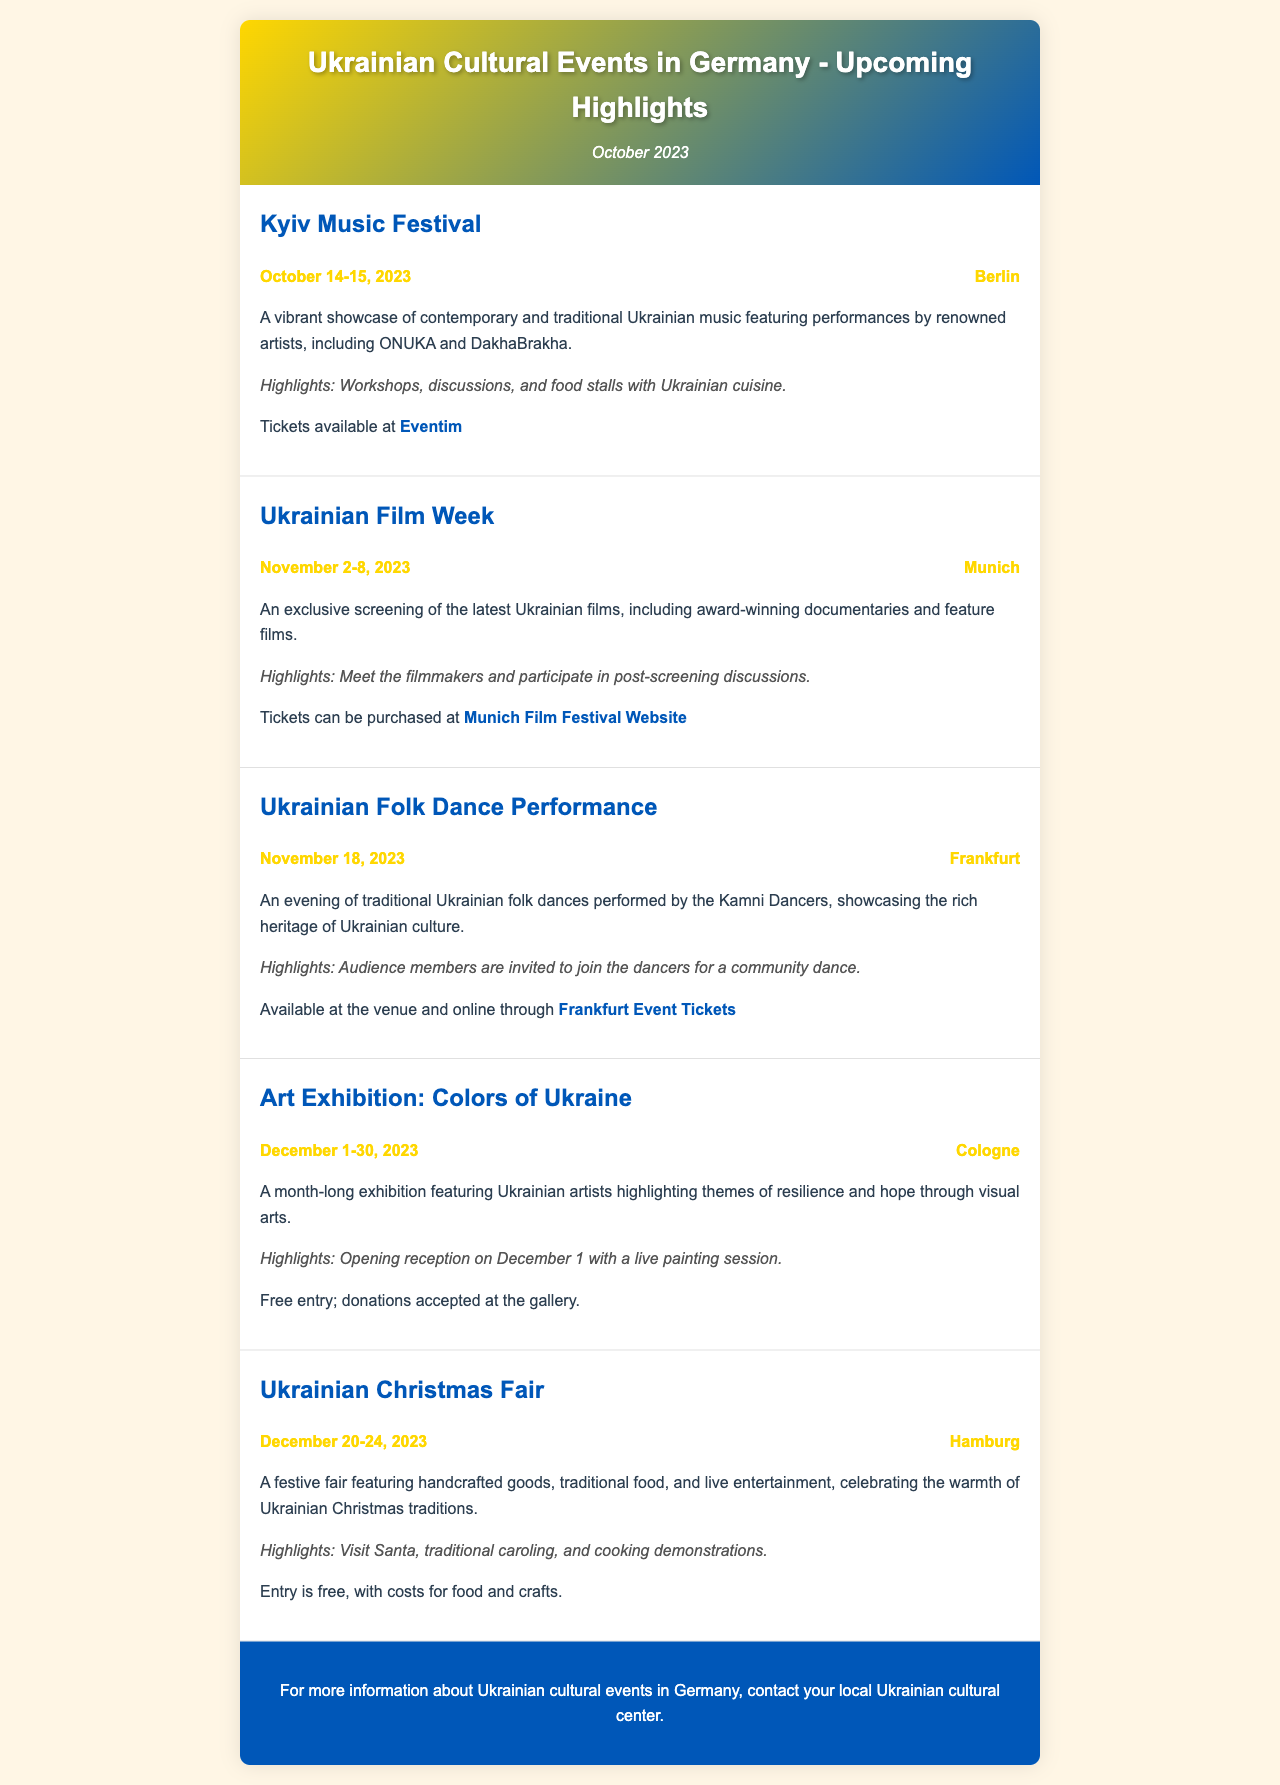What is the name of the festival in Berlin? The document lists the "Kyiv Music Festival" as the festival taking place in Berlin.
Answer: Kyiv Music Festival When is the Ukrainian Film Week scheduled? The document indicates that the Ukrainian Film Week is scheduled for November 2-8, 2023.
Answer: November 2-8, 2023 What is the location of the Art Exhibition? The document states that the Art Exhibition: Colors of Ukraine is taking place in Cologne.
Answer: Cologne Who will be performing at the Ukrainian Folk Dance Performance? The document mentions that the Kamni Dancers will be performing at the Ukrainian Folk Dance Performance.
Answer: Kamni Dancers What type of event is happening in Hamburg from December 20-24, 2023? The document describes a Ukrainian Christmas Fair happening in Hamburg during those dates.
Answer: Ukrainian Christmas Fair What can visitors expect at the "Kyiv Music Festival"? The document highlights workshops, discussions, and food stalls with Ukrainian cuisine as features of the event.
Answer: Workshops, discussions, food stalls How long will the exhibit "Colors of Ukraine" be open? The document specifies that the exhibit will be open for a month, from December 1-30, 2023.
Answer: December 1-30, 2023 Is entry to the Art Exhibition free? The document states that the entry to the exhibition is free, with donations accepted.
Answer: Free entry What activities are mentioned for the Ukrainian Christmas Fair? The document details traditional caroling and cooking demonstrations as activities at the fair.
Answer: Traditional caroling, cooking demonstrations 